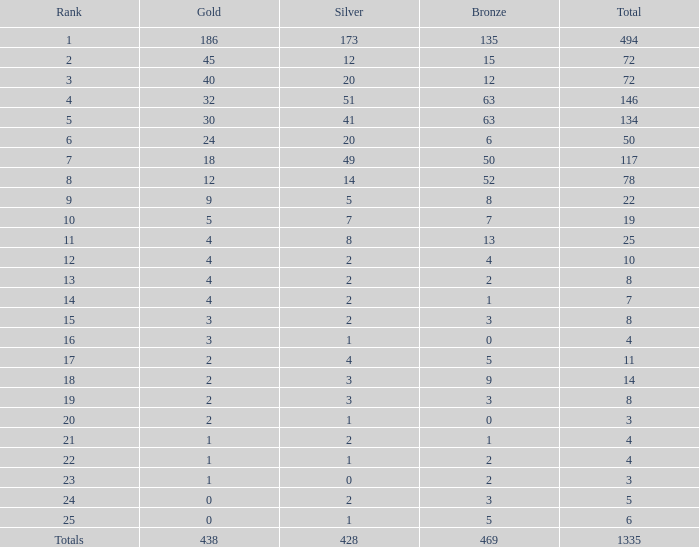What is the average number of gold medals when the total was 1335 medals, with more than 469 bronzes and more than 14 silvers? None. 